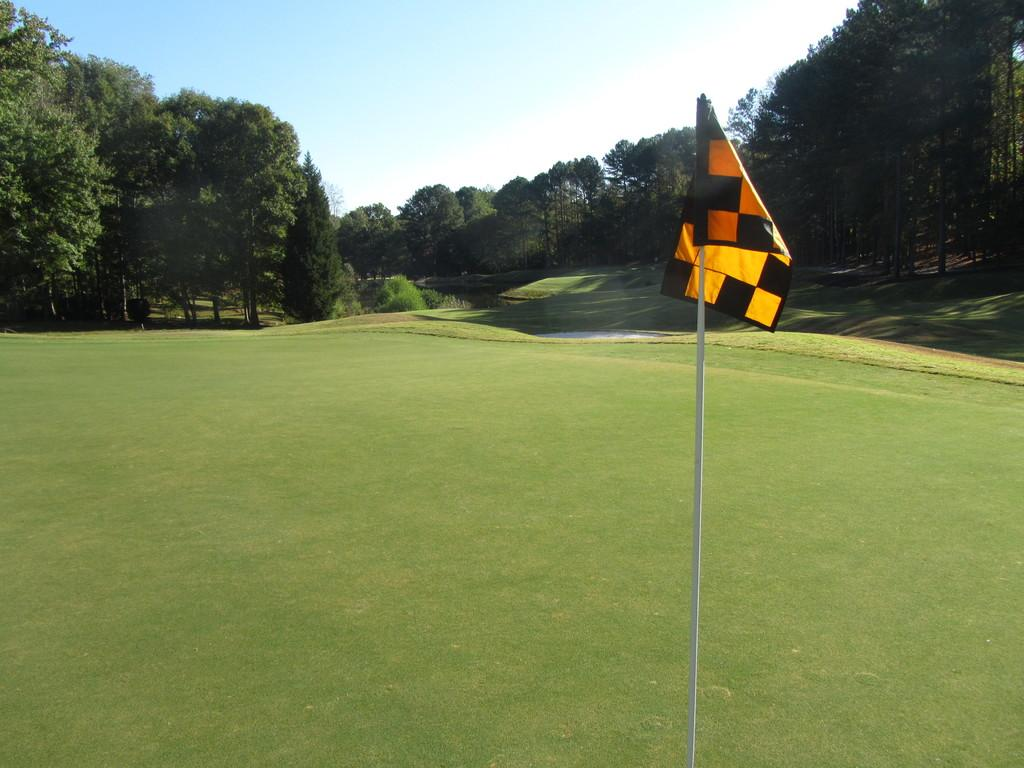What is the main object in the image? There is a flag in the image. Where is the flag located? The flag is located in a grassy land. What can be seen in the background of the image? There are trees in the background of the image. What is visible at the top of the image? The sky is visible at the top of the image. What type of rice is being harvested in the image? There is no rice or harvesting activity present in the image; it features a flag in a grassy land with trees in the background and the sky visible at the top. 